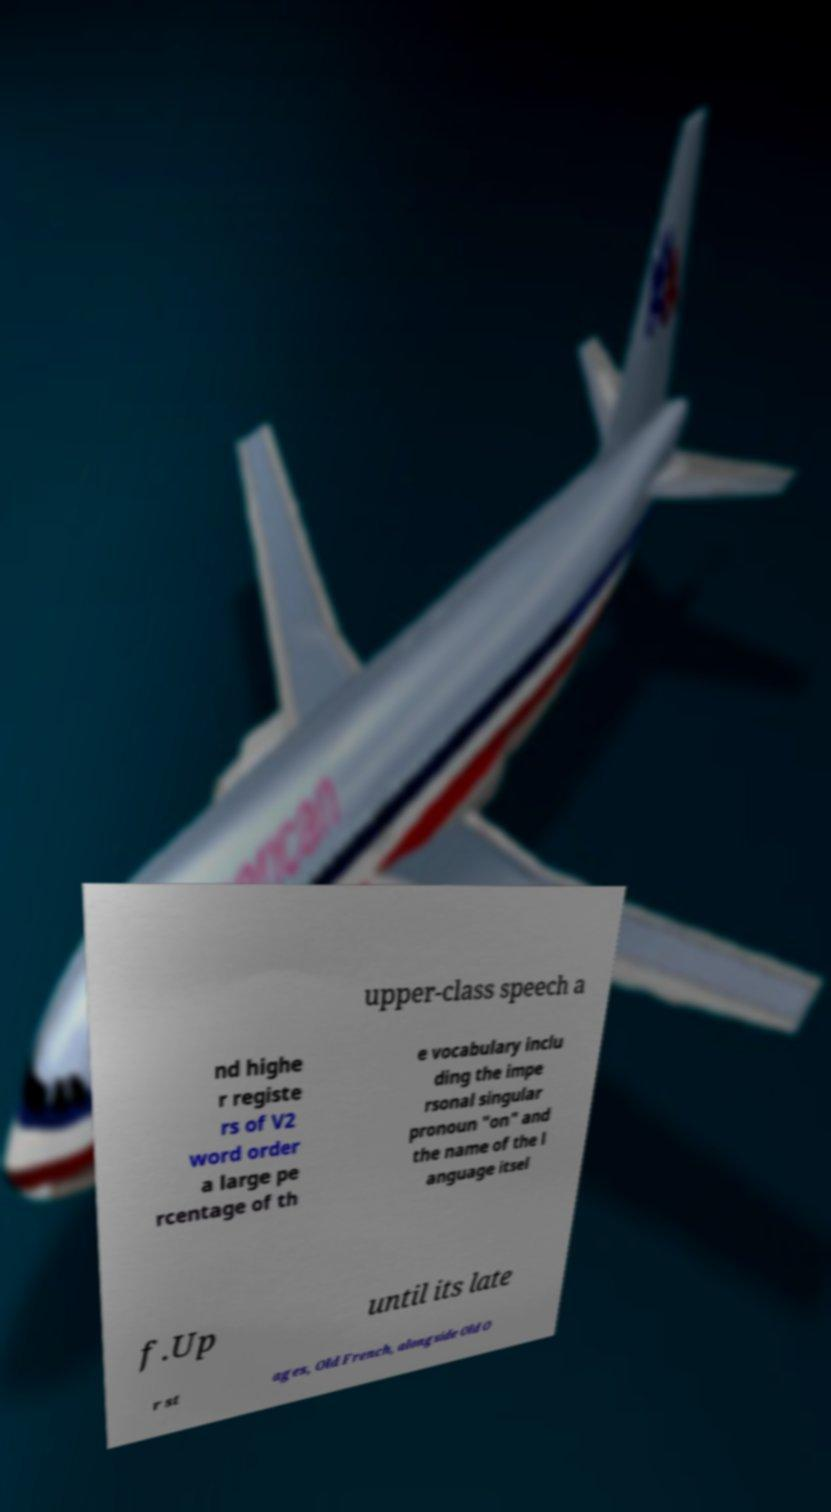Please identify and transcribe the text found in this image. upper-class speech a nd highe r registe rs of V2 word order a large pe rcentage of th e vocabulary inclu ding the impe rsonal singular pronoun "on" and the name of the l anguage itsel f.Up until its late r st ages, Old French, alongside Old O 